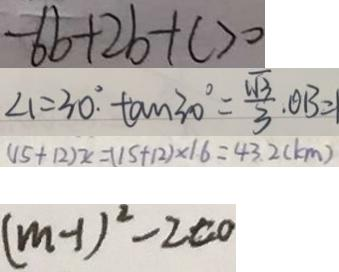<formula> <loc_0><loc_0><loc_500><loc_500>- 6 b + 2 b + c > 0 
 \angle 1 = 3 0 ^ { \circ } . \tan 3 0 ^ { \circ } = \frac { \sqrt { 3 } } { 3 } . O B = 
 ( 1 5 + 1 2 ) x = ( 1 5 + 1 2 ) \times 1 6 = 4 3 . 2 ( k m ) 
 ( m - 1 ) ^ { 2 } - 2 c o</formula> 